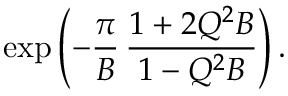<formula> <loc_0><loc_0><loc_500><loc_500>\exp \left ( - \frac { \pi } { B } \, \frac { 1 + 2 Q ^ { 2 } B } { 1 - Q ^ { 2 } B } \right ) .</formula> 